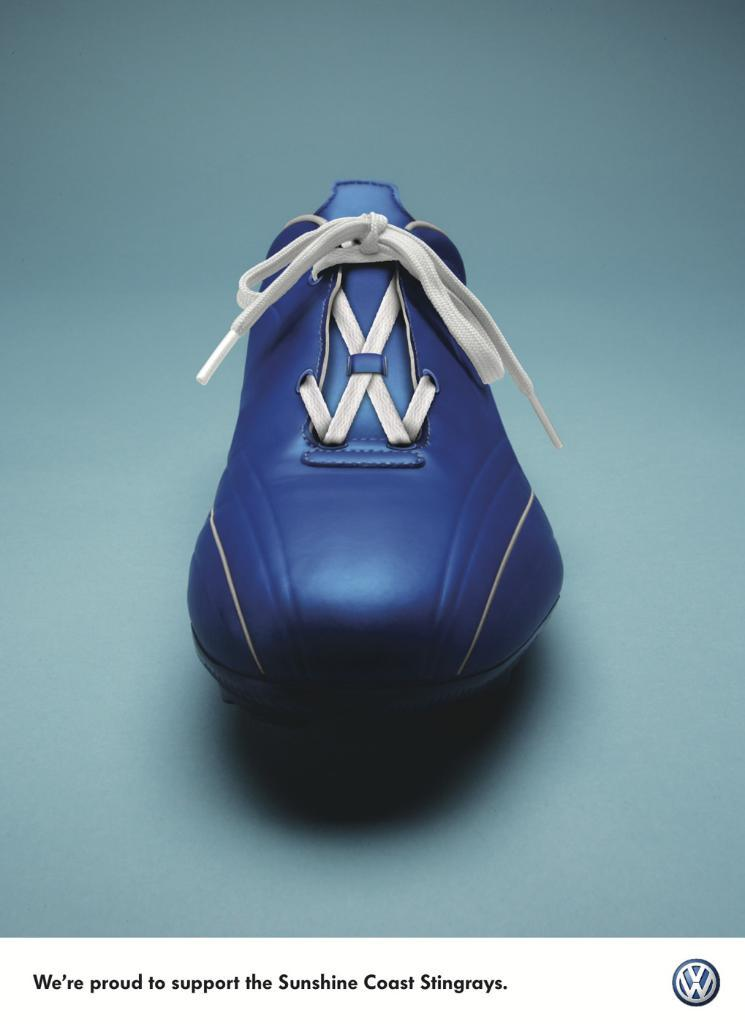<image>
Share a concise interpretation of the image provided. A soccer shoe in an ad by Volkswagen 